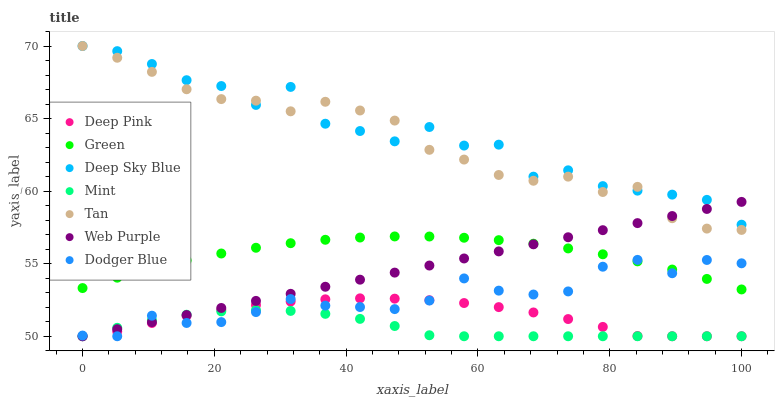Does Mint have the minimum area under the curve?
Answer yes or no. Yes. Does Deep Sky Blue have the maximum area under the curve?
Answer yes or no. Yes. Does Web Purple have the minimum area under the curve?
Answer yes or no. No. Does Web Purple have the maximum area under the curve?
Answer yes or no. No. Is Web Purple the smoothest?
Answer yes or no. Yes. Is Deep Sky Blue the roughest?
Answer yes or no. Yes. Is Green the smoothest?
Answer yes or no. No. Is Green the roughest?
Answer yes or no. No. Does Deep Pink have the lowest value?
Answer yes or no. Yes. Does Green have the lowest value?
Answer yes or no. No. Does Tan have the highest value?
Answer yes or no. Yes. Does Web Purple have the highest value?
Answer yes or no. No. Is Dodger Blue less than Tan?
Answer yes or no. Yes. Is Green greater than Mint?
Answer yes or no. Yes. Does Web Purple intersect Deep Sky Blue?
Answer yes or no. Yes. Is Web Purple less than Deep Sky Blue?
Answer yes or no. No. Is Web Purple greater than Deep Sky Blue?
Answer yes or no. No. Does Dodger Blue intersect Tan?
Answer yes or no. No. 